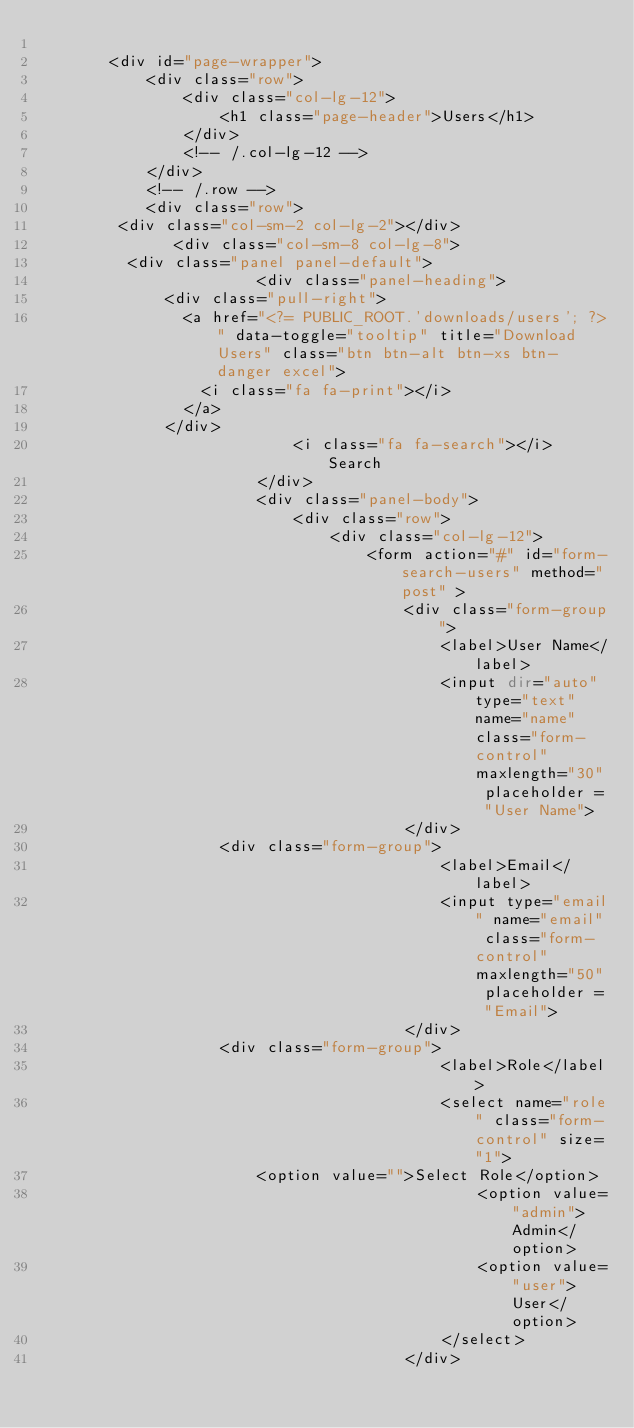<code> <loc_0><loc_0><loc_500><loc_500><_PHP_>
        <div id="page-wrapper">
            <div class="row">
                <div class="col-lg-12">
                    <h1 class="page-header">Users</h1>
                </div>
                <!-- /.col-lg-12 -->
            </div>
            <!-- /.row -->
            <div class="row">
			   <div class="col-sm-2 col-lg-2"></div>
               <div class="col-sm-8 col-lg-8">
					<div class="panel panel-default">
                        <div class="panel-heading">
							<div class="pull-right">
								<a href="<?= PUBLIC_ROOT.'downloads/users'; ?>" data-toggle="tooltip" title="Download Users" class="btn btn-alt btn-xs btn-danger excel">
									<i class="fa fa-print"></i>
								</a>
							</div>
                            <i class="fa fa-search"></i> Search
                        </div>
                        <div class="panel-body">
                            <div class="row">
                                <div class="col-lg-12">
                                    <form action="#" id="form-search-users" method="post" >
                                        <div class="form-group">
                                            <label>User Name</label>
                                            <input dir="auto" type="text" name="name" class="form-control" maxlength="30" placeholder = "User Name">
                                        </div>
										<div class="form-group">
                                            <label>Email</label>
                                            <input type="email" name="email" class="form-control" maxlength="50" placeholder = "Email">
                                        </div>
										<div class="form-group">
                                            <label>Role</label>
                                            <select name="role" class="form-control" size="1">
												<option value="">Select Role</option>
                                                <option value="admin">Admin</option>
                                                <option value="user">User</option>
                                            </select>
                                        </div></code> 